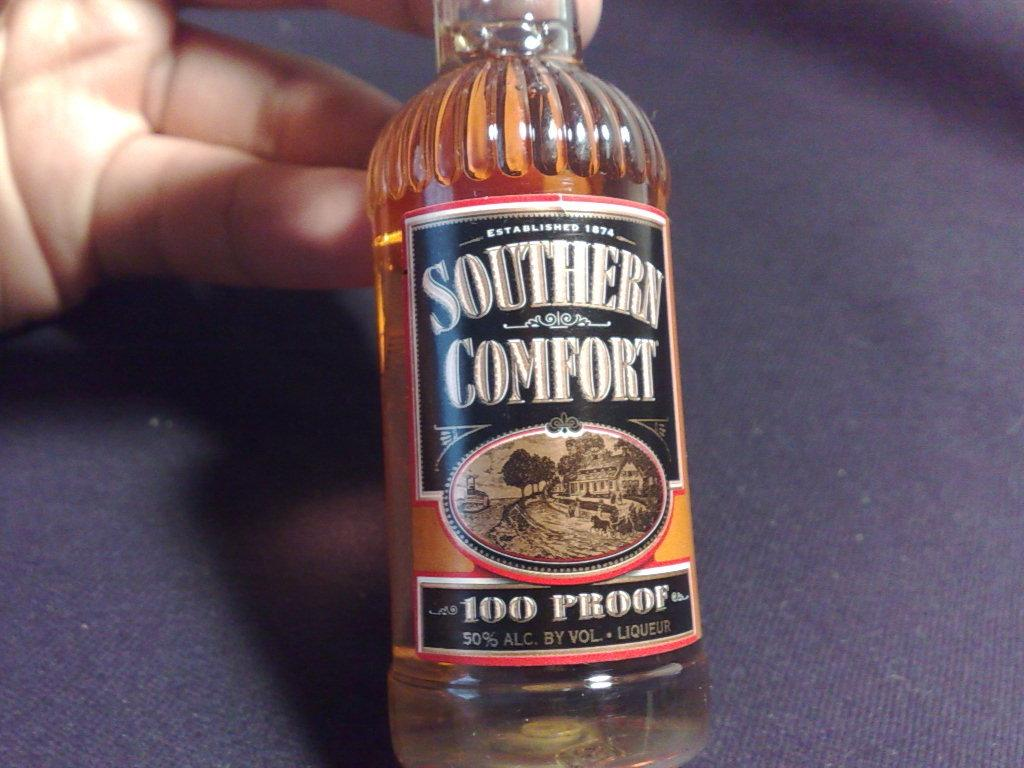<image>
Summarize the visual content of the image. Person holding a Southern Comfort beer that is 100 Proof. 